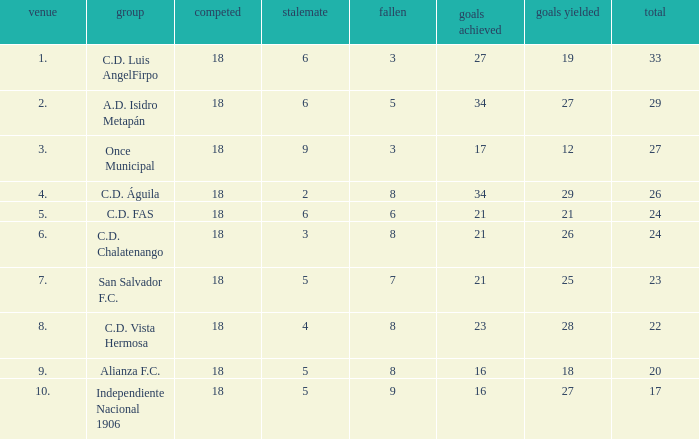What's the place that Once Municipal has a lost greater than 3? None. 